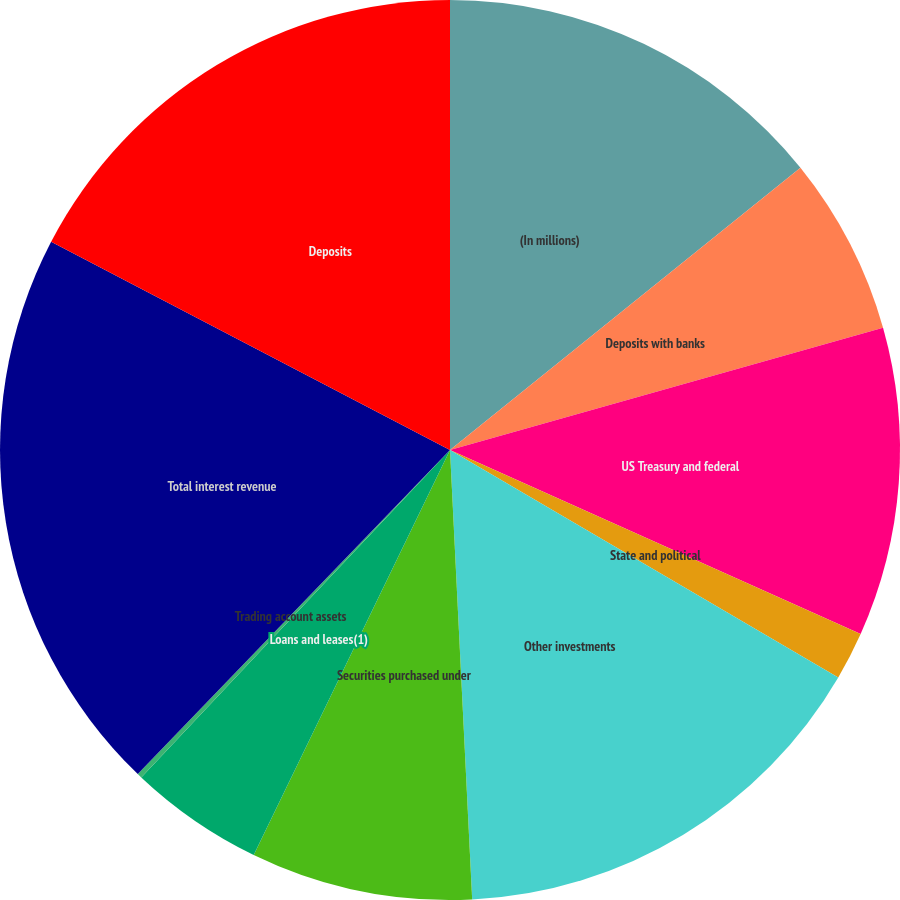Convert chart to OTSL. <chart><loc_0><loc_0><loc_500><loc_500><pie_chart><fcel>(In millions)<fcel>Deposits with banks<fcel>US Treasury and federal<fcel>State and political<fcel>Other investments<fcel>Securities purchased under<fcel>Loans and leases(1)<fcel>Trading account assets<fcel>Total interest revenue<fcel>Deposits<nl><fcel>14.21%<fcel>6.41%<fcel>11.09%<fcel>1.73%<fcel>15.78%<fcel>7.97%<fcel>4.85%<fcel>0.17%<fcel>20.46%<fcel>17.34%<nl></chart> 